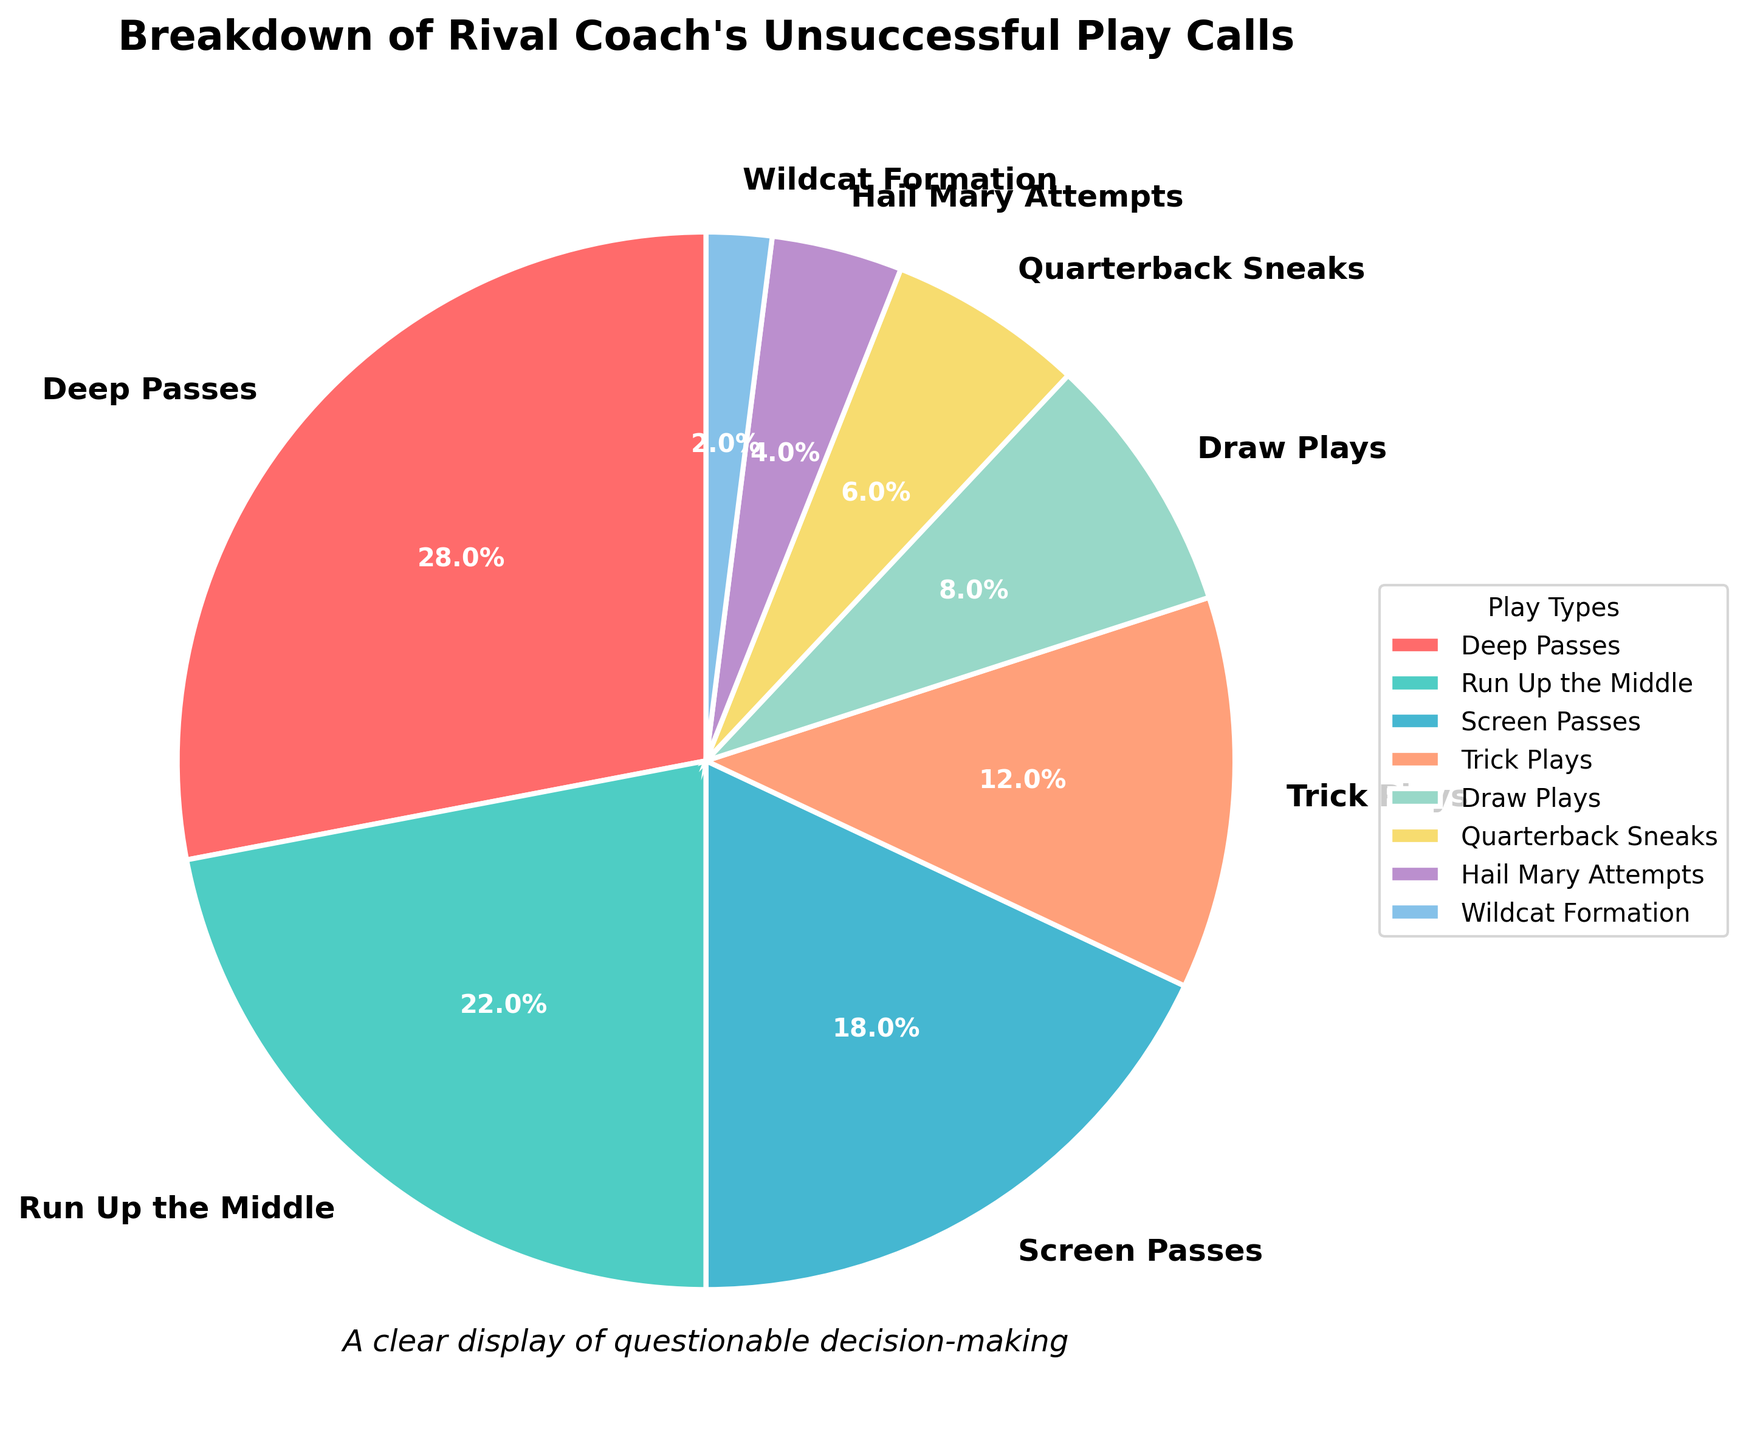How many types of unsuccessful play calls constitute more than 10% of the total plays? The pie chart shows the percentage for each play type. By checking the percentages, we see that Deep Passes (28%), Run Up the Middle (22%), Screen Passes (18%), and Trick Plays (12%) are all more than 10%. Thus, there are four types.
Answer: Four Which play type has the least percentage of unsuccessful play calls? To find the smallest percentage, check all the segments, and you will see that Wildcat Formation has the smallest slice at 2%.
Answer: Wildcat Formation Is the combined percentage of Deep Passes and Run Up the Middle more than 50%? The percentage of Deep Passes is 28% and Run Up the Middle is 22%. Adding these together, 28% + 22% = 50%, which means they exactly make up half of the total.
Answer: No How much more prevalent are Deep Passes than Screen Passes? Deep Passes account for 28%, while Screen Passes account for 18%. The difference between them is 28% - 18% = 10%.
Answer: 10% What is the combined percentage of Draw Plays, Quarterback Sneaks, and Hail Mary Attempts? Add the percentages for Draw Plays (8%), Quarterback Sneaks (6%), and Hail Mary Attempts (4%). The sum is 8% + 6% + 4% = 18%.
Answer: 18% Which types of play calls have percentages within a 2% range of Draw Plays? Draw Plays are at 8%. Trick Plays at 12%, Quarterback Sneaks at 6%, Hail Mary Attempts at 4%, and Wildcat Formation at 2% are not within 2% range. There are no play types within a 2% range of Draw Plays.
Answer: None Which play types are represented with shades of green? Viewing the segments, Run Up the Middle and Screen Passes are represented with shades of green.
Answer: Run Up the Middle, Screen Passes What is the percentage difference between Trick Plays and Quarterback Sneaks? Trick Plays have a percentage of 12%, and Quarterback Sneaks have a percentage of 6%. The difference is 12% - 6% = 6%.
Answer: 6% Among the play types with unsuccessful calls, which one falls exactly in the middle when sorting by percentage? When arranged in order—Wildcat Formation (2%), Hail Mary Attempts (4%), Quarterback Sneaks (6%), Draw Plays (8%), Trick Plays (12%), Screen Passes (18%), Run Up the Middle (22%), Deep Passes (28%)—Draw Plays falls in the middle value.
Answer: Draw Plays What percentage of play calls are less than 10% unsuccessful? Add up the percentages of the play types under 10%: Quarterback Sneaks (6%), Hail Mary Attempts (4%), Wildcat Formation (2%). The total is 6% + 4% + 2% = 12%.
Answer: 12% 